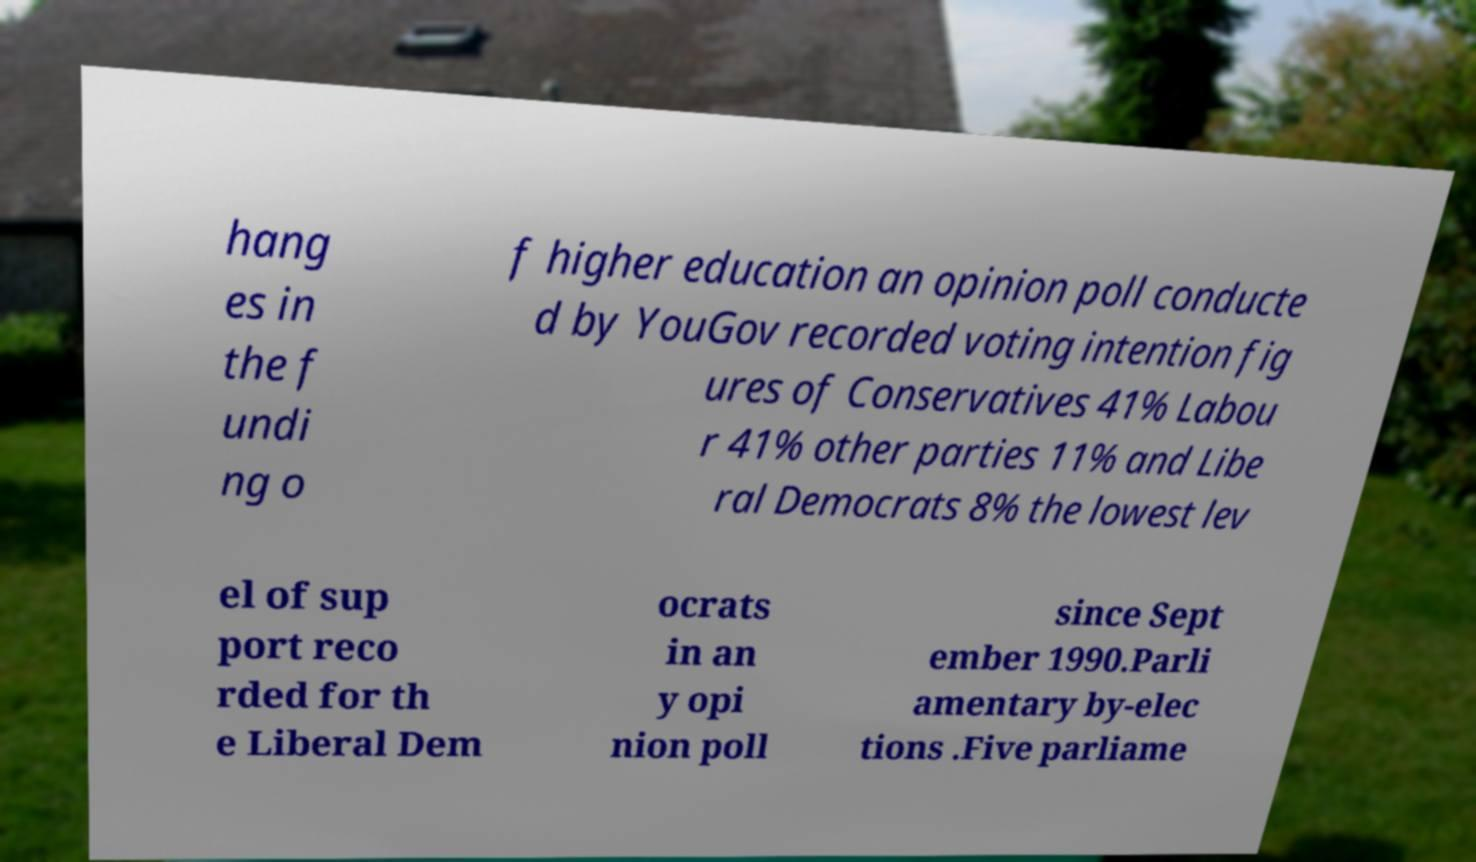Could you extract and type out the text from this image? hang es in the f undi ng o f higher education an opinion poll conducte d by YouGov recorded voting intention fig ures of Conservatives 41% Labou r 41% other parties 11% and Libe ral Democrats 8% the lowest lev el of sup port reco rded for th e Liberal Dem ocrats in an y opi nion poll since Sept ember 1990.Parli amentary by-elec tions .Five parliame 